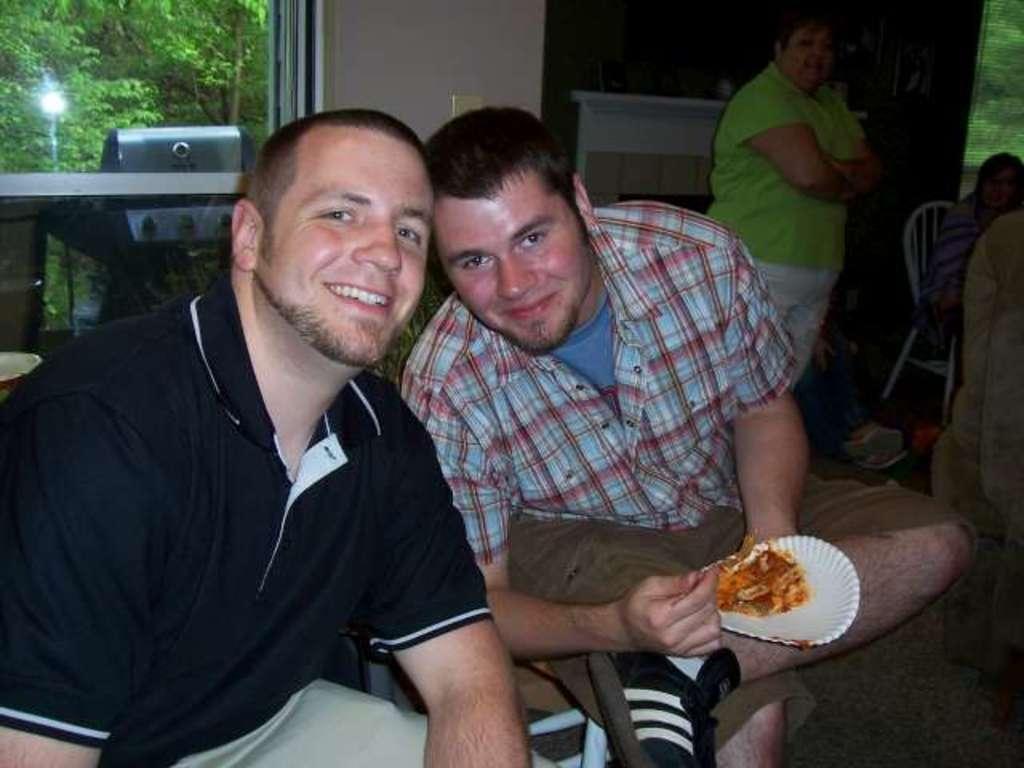Could you give a brief overview of what you see in this image? There are two persons sitting as we can see at the bottom of this image. The person on the left side is wearing black color t shirt, and the person on the right side is holding a plate. There are some other persons standing, and one person is sitting on the chair is on the right side of this image. There is a wall in the background. There is a glass window on the left side of this image. We can see there are some trees at the top left corner of this image. 